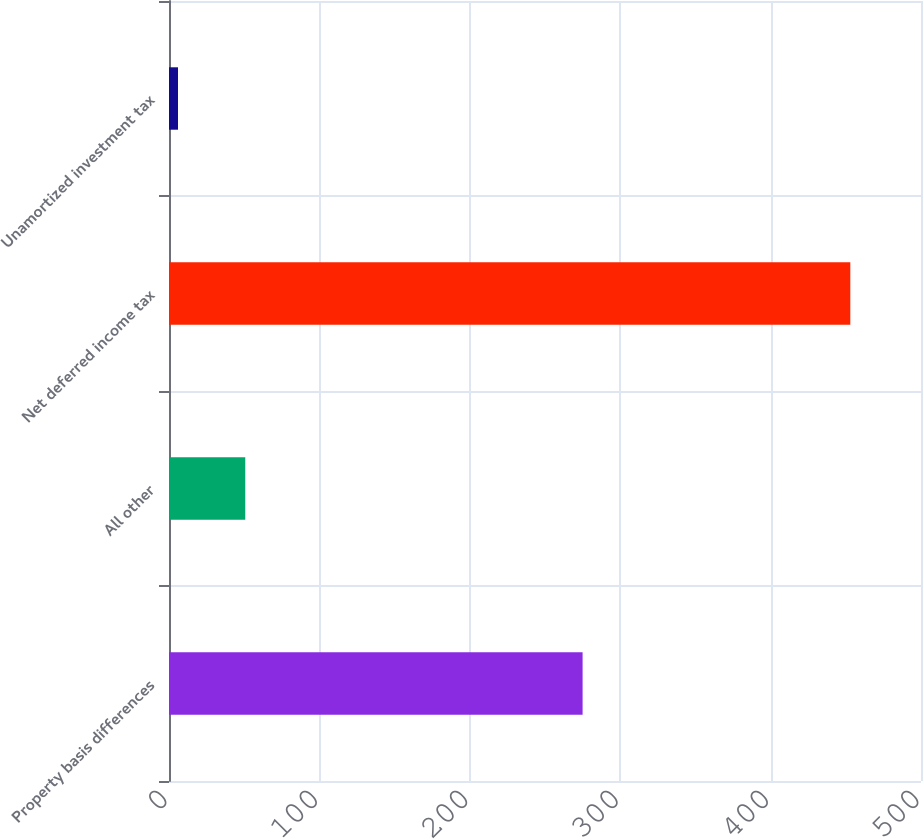Convert chart. <chart><loc_0><loc_0><loc_500><loc_500><bar_chart><fcel>Property basis differences<fcel>All other<fcel>Net deferred income tax<fcel>Unamortized investment tax<nl><fcel>275<fcel>50.7<fcel>453<fcel>6<nl></chart> 